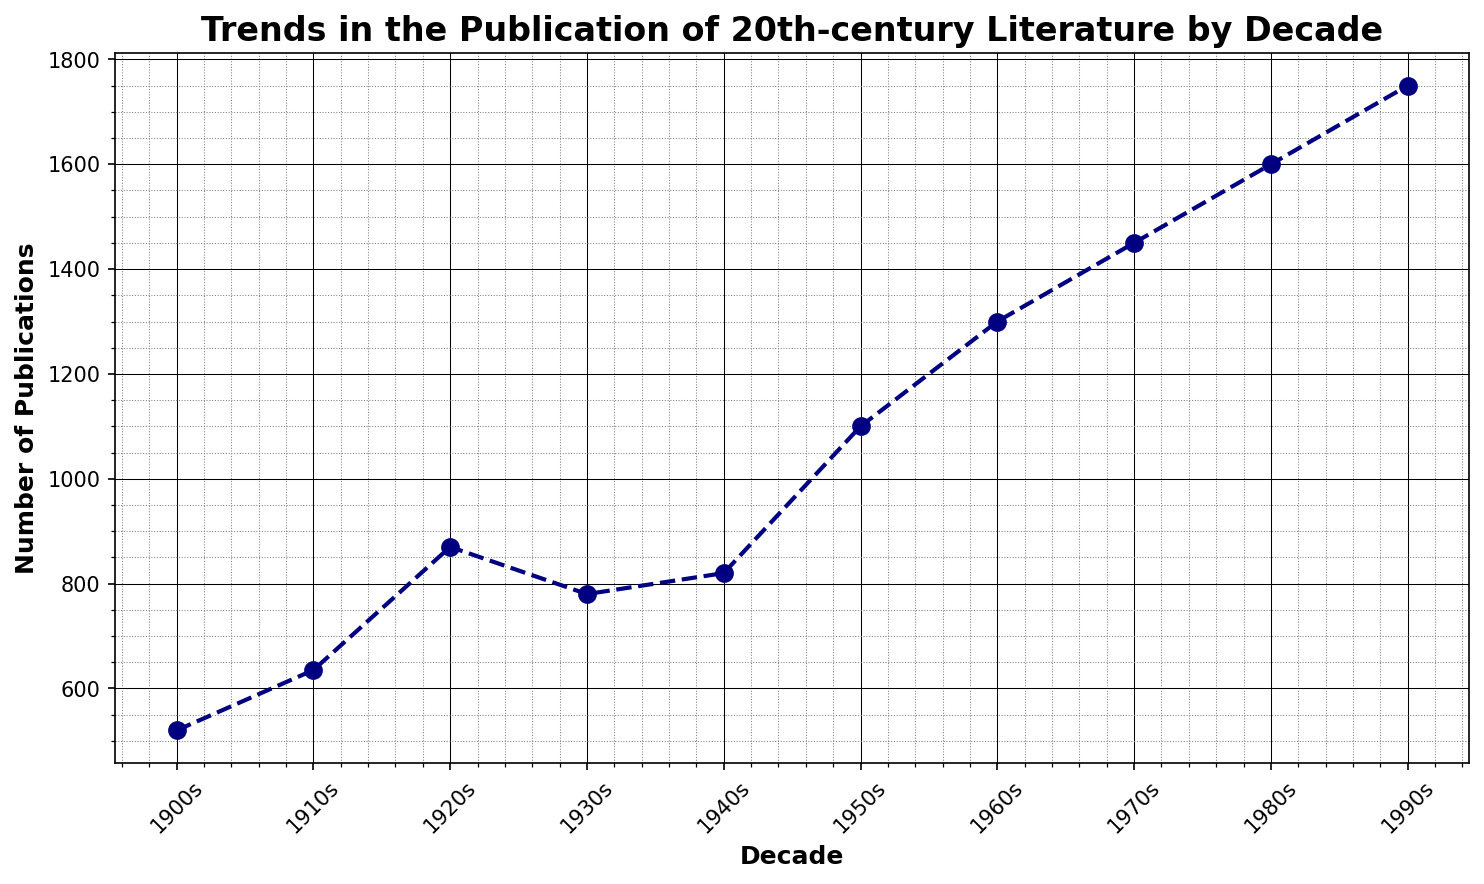Which decade saw the highest number of publications? By looking at the data points on the line plot, the highest peak indicates the decade with the most publications. This peak is at 1990s with 1750 publications.
Answer: 1990s Which decade had the fewest publications? By finding the lowest point on the graph, we can identify the decade with the fewest publications. The lowest point is at the 1900s with 520 publications.
Answer: 1900s What is the difference in the number of publications between the 1980s and the 1920s? First, find the number of publications for the 1980s (1600) and the 1920s (870). Then subtract the 1920s value from the 1980s value: 1600 - 870 = 730.
Answer: 730 What is the average number of publications per decade from the 1900s to the 1990s? Add the number of publications for each decade (520 + 635 + 870 + 780 + 820 + 1100 + 1300 + 1450 + 1600 + 1750) and then divide by the number of decades (10). Sum is 11825, so the average is 11825 / 10 = 1182.5.
Answer: 1182.5 Did the number of publications continuously increase every decade? By visually examining the plot, check if the line continuously rises without any dips. There is a dip between the 1920s and 1930s, and between the 1930s and 1940s, indicating it did not continuously increase.
Answer: No Between which two consecutive decades was the drop in publications the greatest? To find this, compare each consecutive decade pair by subtracting the later decade's publications from the earlier decade's publications. The greatest drop is from the 1920s (870) to the 1930s (780), a drop of 90.
Answer: 1920s to 1930s What was the overall trend in the number of publications through the century? By examining the general shape of the plot, we can see an overall upward trend in the number of publications from the 1900s to the 1990s.
Answer: Upward trend How many more publications were there in the 1950s compared to the 1900s? First, find the number of publications for both decades; 1100 in the 1950s and 520 in the 1900s. Then, subtract the 1900s value from the 1950s value: 1100 - 520 = 580.
Answer: 580 What is the rate of increase in publications from the 1960s to the 1970s? Calculate the difference in the number of publications between the 1960s (1300) and the 1970s (1450), and then divide by the number of years in a decade (10). 1450 - 1300 = 150. The rate of increase is 150 / 10 = 15 per year.
Answer: 15 per year 